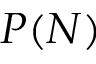Convert formula to latex. <formula><loc_0><loc_0><loc_500><loc_500>P ( N )</formula> 